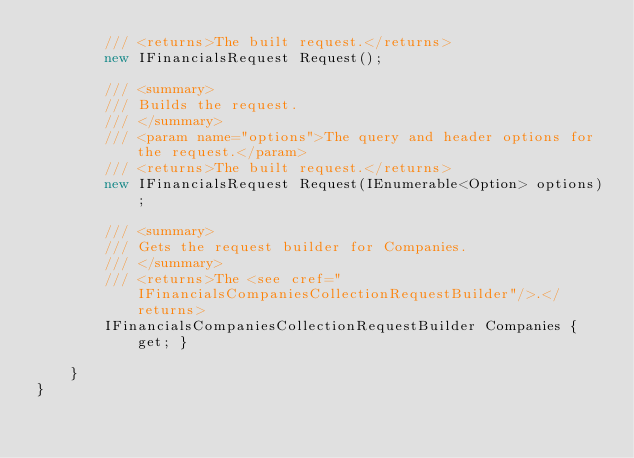Convert code to text. <code><loc_0><loc_0><loc_500><loc_500><_C#_>        /// <returns>The built request.</returns>
        new IFinancialsRequest Request();

        /// <summary>
        /// Builds the request.
        /// </summary>
        /// <param name="options">The query and header options for the request.</param>
        /// <returns>The built request.</returns>
        new IFinancialsRequest Request(IEnumerable<Option> options);
    
        /// <summary>
        /// Gets the request builder for Companies.
        /// </summary>
        /// <returns>The <see cref="IFinancialsCompaniesCollectionRequestBuilder"/>.</returns>
        IFinancialsCompaniesCollectionRequestBuilder Companies { get; }
    
    }
}
</code> 